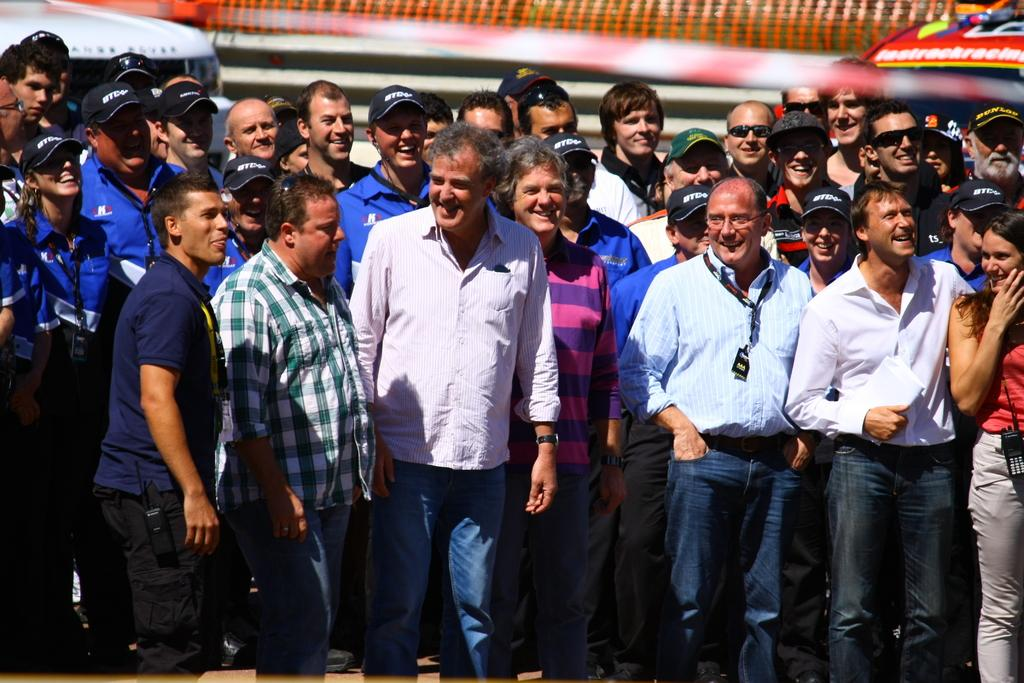Who or what is present in the image? There are people in the image. What is the facial expression of the people in the image? The people are smiling. What can be seen in the background of the image? There is a net fence and other objects visible in the background of the image. What type of orange is being used as a ball in the image? There is no orange or ball present in the image. Is there a prison visible in the image? There is no prison present in the image. 